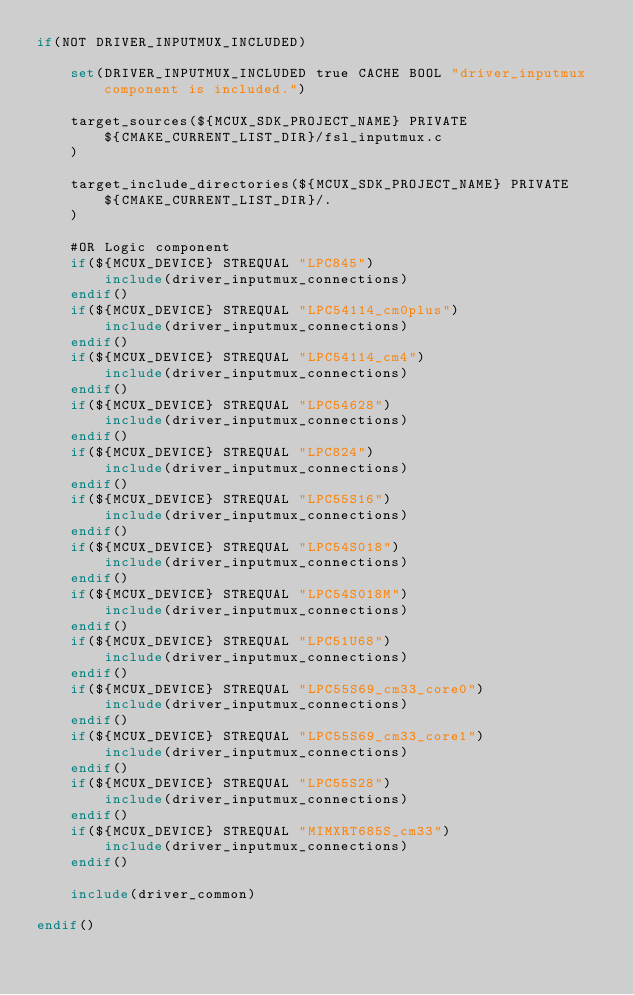<code> <loc_0><loc_0><loc_500><loc_500><_CMake_>if(NOT DRIVER_INPUTMUX_INCLUDED)

    set(DRIVER_INPUTMUX_INCLUDED true CACHE BOOL "driver_inputmux component is included.")

    target_sources(${MCUX_SDK_PROJECT_NAME} PRIVATE
        ${CMAKE_CURRENT_LIST_DIR}/fsl_inputmux.c
    )

    target_include_directories(${MCUX_SDK_PROJECT_NAME} PRIVATE
        ${CMAKE_CURRENT_LIST_DIR}/.
    )

    #OR Logic component
    if(${MCUX_DEVICE} STREQUAL "LPC845")
        include(driver_inputmux_connections)
    endif()
    if(${MCUX_DEVICE} STREQUAL "LPC54114_cm0plus")
        include(driver_inputmux_connections)
    endif()
    if(${MCUX_DEVICE} STREQUAL "LPC54114_cm4")
        include(driver_inputmux_connections)
    endif()
    if(${MCUX_DEVICE} STREQUAL "LPC54628")
        include(driver_inputmux_connections)
    endif()
    if(${MCUX_DEVICE} STREQUAL "LPC824")
        include(driver_inputmux_connections)
    endif()
    if(${MCUX_DEVICE} STREQUAL "LPC55S16")
        include(driver_inputmux_connections)
    endif()
    if(${MCUX_DEVICE} STREQUAL "LPC54S018")
        include(driver_inputmux_connections)
    endif()
    if(${MCUX_DEVICE} STREQUAL "LPC54S018M")
        include(driver_inputmux_connections)
    endif()
    if(${MCUX_DEVICE} STREQUAL "LPC51U68")
        include(driver_inputmux_connections)
    endif()
    if(${MCUX_DEVICE} STREQUAL "LPC55S69_cm33_core0")
        include(driver_inputmux_connections)
    endif()
    if(${MCUX_DEVICE} STREQUAL "LPC55S69_cm33_core1")
        include(driver_inputmux_connections)
    endif()
    if(${MCUX_DEVICE} STREQUAL "LPC55S28")
        include(driver_inputmux_connections)
    endif()
    if(${MCUX_DEVICE} STREQUAL "MIMXRT685S_cm33")
        include(driver_inputmux_connections)
    endif()

    include(driver_common)

endif()</code> 